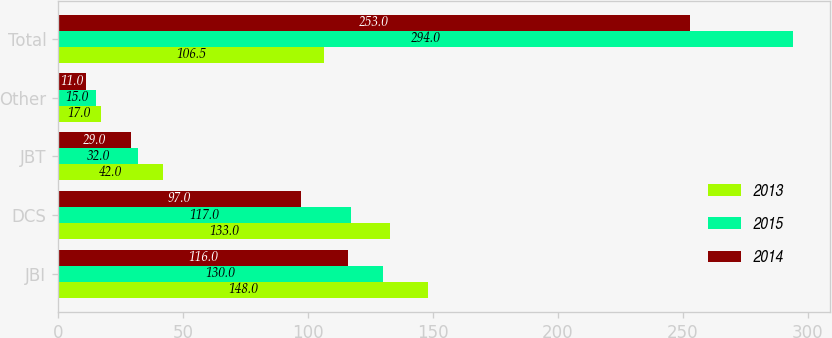<chart> <loc_0><loc_0><loc_500><loc_500><stacked_bar_chart><ecel><fcel>JBI<fcel>DCS<fcel>JBT<fcel>Other<fcel>Total<nl><fcel>2013<fcel>148<fcel>133<fcel>42<fcel>17<fcel>106.5<nl><fcel>2015<fcel>130<fcel>117<fcel>32<fcel>15<fcel>294<nl><fcel>2014<fcel>116<fcel>97<fcel>29<fcel>11<fcel>253<nl></chart> 